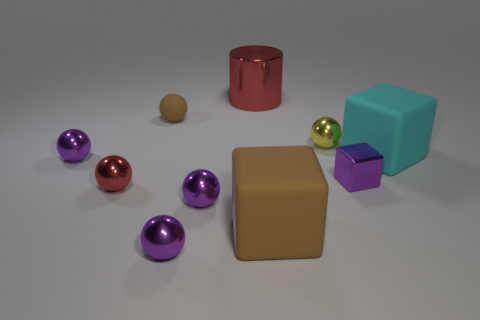Subtract all green cylinders. How many purple spheres are left? 3 Subtract all yellow spheres. How many spheres are left? 5 Subtract all tiny yellow balls. How many balls are left? 5 Subtract all blue spheres. Subtract all brown cylinders. How many spheres are left? 6 Subtract all cubes. How many objects are left? 7 Add 4 small yellow metal spheres. How many small yellow metal spheres are left? 5 Add 2 large green matte spheres. How many large green matte spheres exist? 2 Subtract 0 green spheres. How many objects are left? 10 Subtract all tiny cyan things. Subtract all red things. How many objects are left? 8 